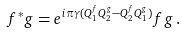Convert formula to latex. <formula><loc_0><loc_0><loc_500><loc_500>f ^ { * } g = e ^ { i \pi \gamma ( Q ^ { f } _ { 1 } Q ^ { g } _ { 2 } - Q ^ { f } _ { 2 } Q ^ { g } _ { 1 } ) } f g \, .</formula> 